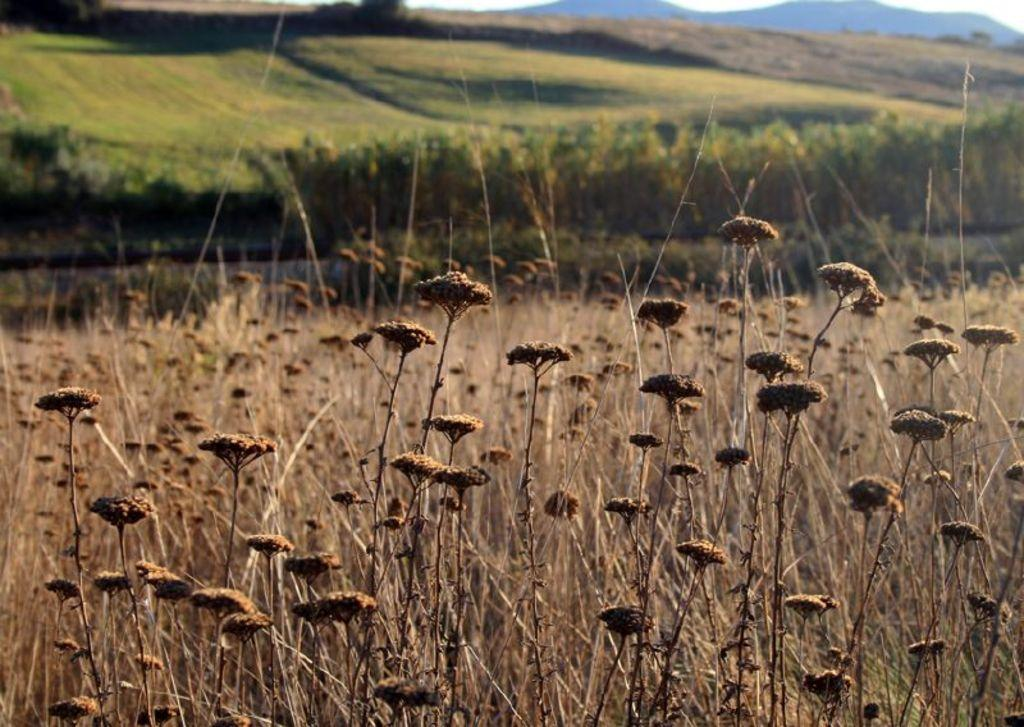What can be seen in the foreground of the image? There are flowers and grass in the foreground of the image. What type of vegetation is visible at the top of the image? There is greenery visible at the top of the image. What geographical feature can be seen at the top of the image? There are mountains visible at the top of the image. How many pizzas are being served on the grass in the image? There are no pizzas present in the image; it features flowers and grass in the foreground. What type of range can be seen in the image? There is no range visible in the image; it features flowers, grass, greenery, and mountains. 